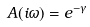<formula> <loc_0><loc_0><loc_500><loc_500>A ( i \omega ) = e ^ { - \gamma }</formula> 